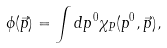Convert formula to latex. <formula><loc_0><loc_0><loc_500><loc_500>\phi ( \vec { p } ) = \int d p ^ { 0 } \chi _ { P } ( p ^ { 0 } , \vec { p } ) ,</formula> 